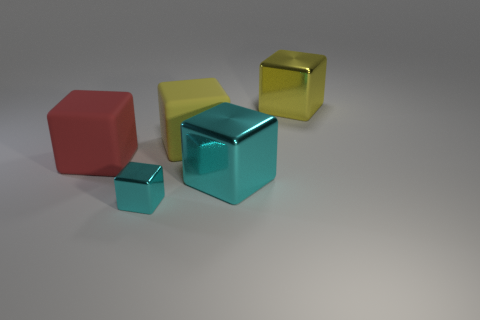Add 2 yellow metallic things. How many objects exist? 7 Subtract all big cyan blocks. How many blocks are left? 4 Subtract all cyan cylinders. How many cyan cubes are left? 2 Subtract 3 cubes. How many cubes are left? 2 Subtract all yellow blocks. How many blocks are left? 3 Subtract all green blocks. Subtract all purple cylinders. How many blocks are left? 5 Subtract all blue cylinders. Subtract all small metallic objects. How many objects are left? 4 Add 4 large red matte objects. How many large red matte objects are left? 5 Add 5 tiny shiny cylinders. How many tiny shiny cylinders exist? 5 Subtract 0 red spheres. How many objects are left? 5 